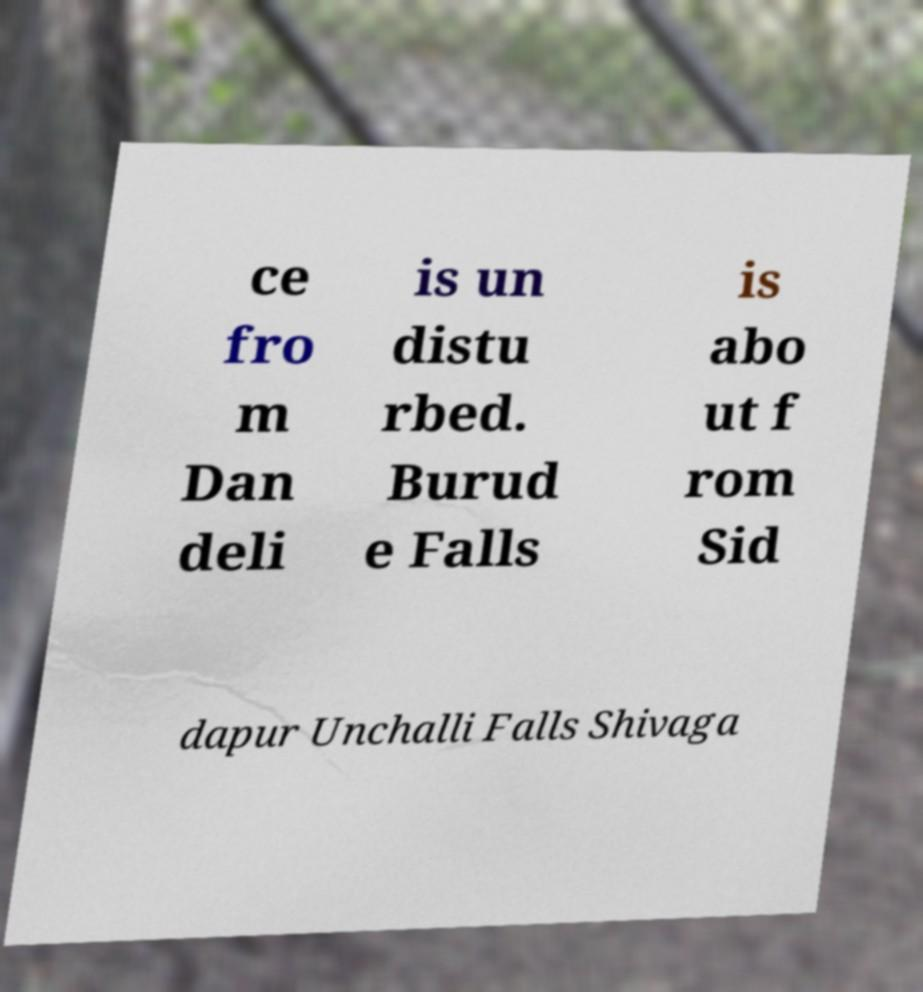Can you read and provide the text displayed in the image?This photo seems to have some interesting text. Can you extract and type it out for me? ce fro m Dan deli is un distu rbed. Burud e Falls is abo ut f rom Sid dapur Unchalli Falls Shivaga 